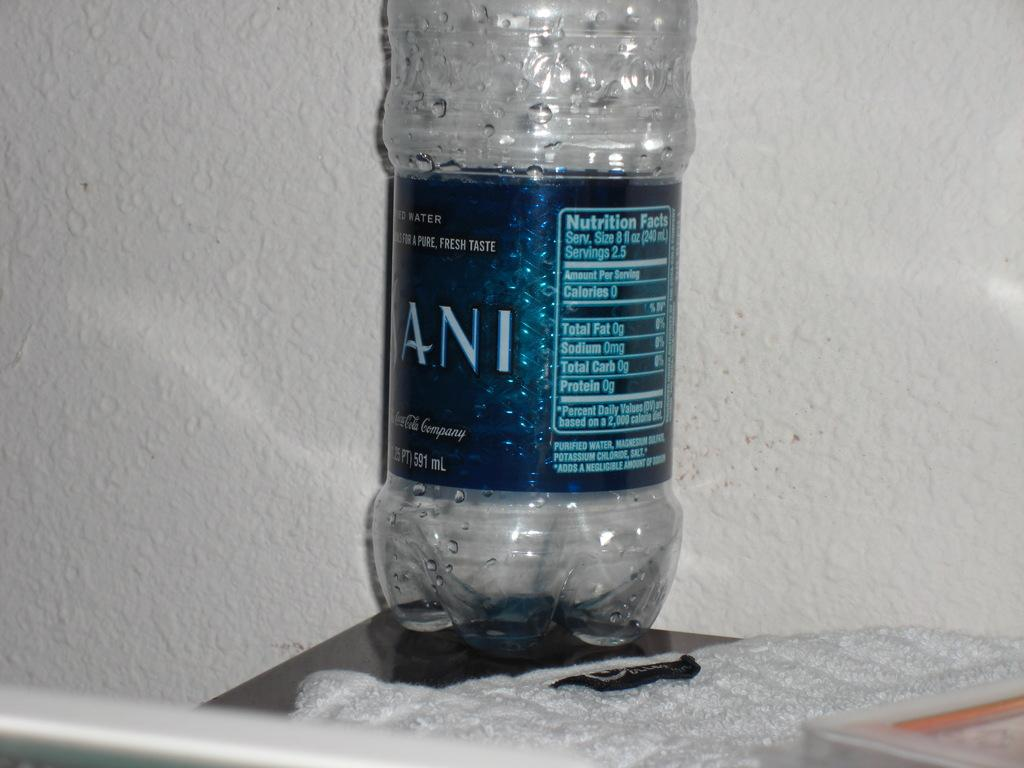<image>
Share a concise interpretation of the image provided. Nutrition facts are on the back of a water bottle. 